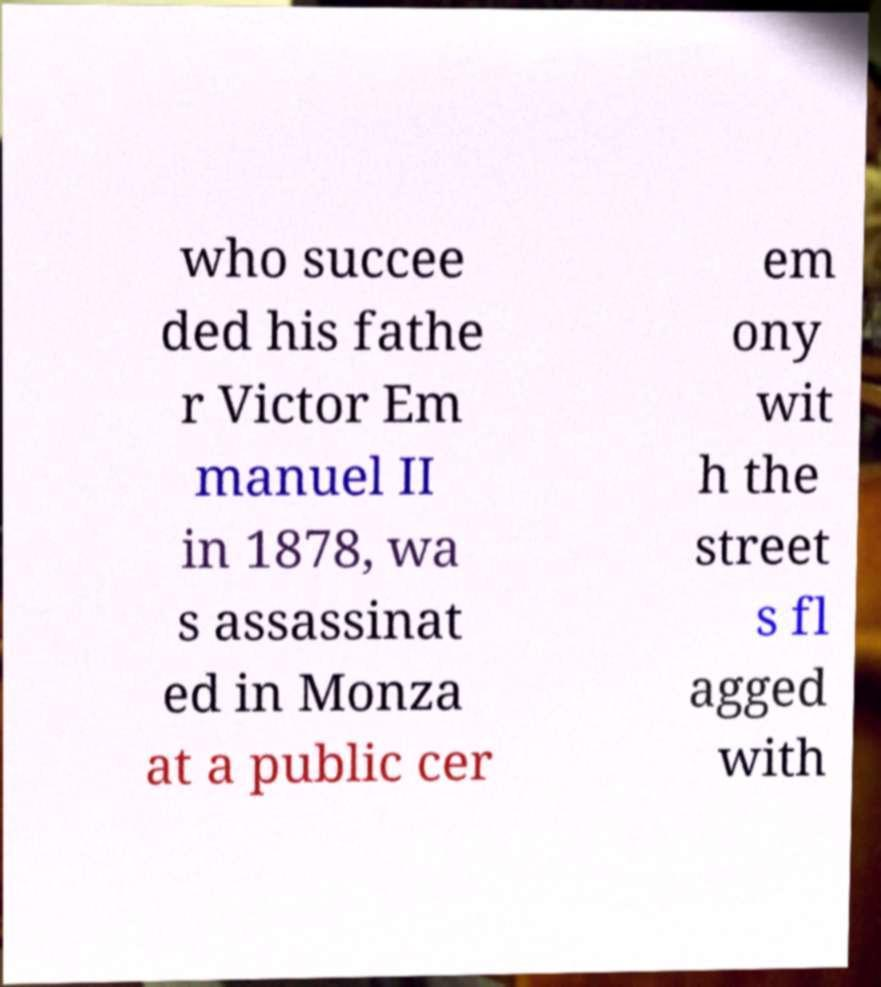For documentation purposes, I need the text within this image transcribed. Could you provide that? who succee ded his fathe r Victor Em manuel II in 1878, wa s assassinat ed in Monza at a public cer em ony wit h the street s fl agged with 